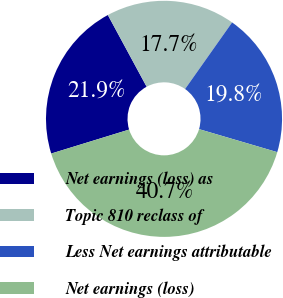Convert chart. <chart><loc_0><loc_0><loc_500><loc_500><pie_chart><fcel>Net earnings (loss) as<fcel>Topic 810 reclass of<fcel>Less Net earnings attributable<fcel>Net earnings (loss)<nl><fcel>21.86%<fcel>17.68%<fcel>19.77%<fcel>40.7%<nl></chart> 